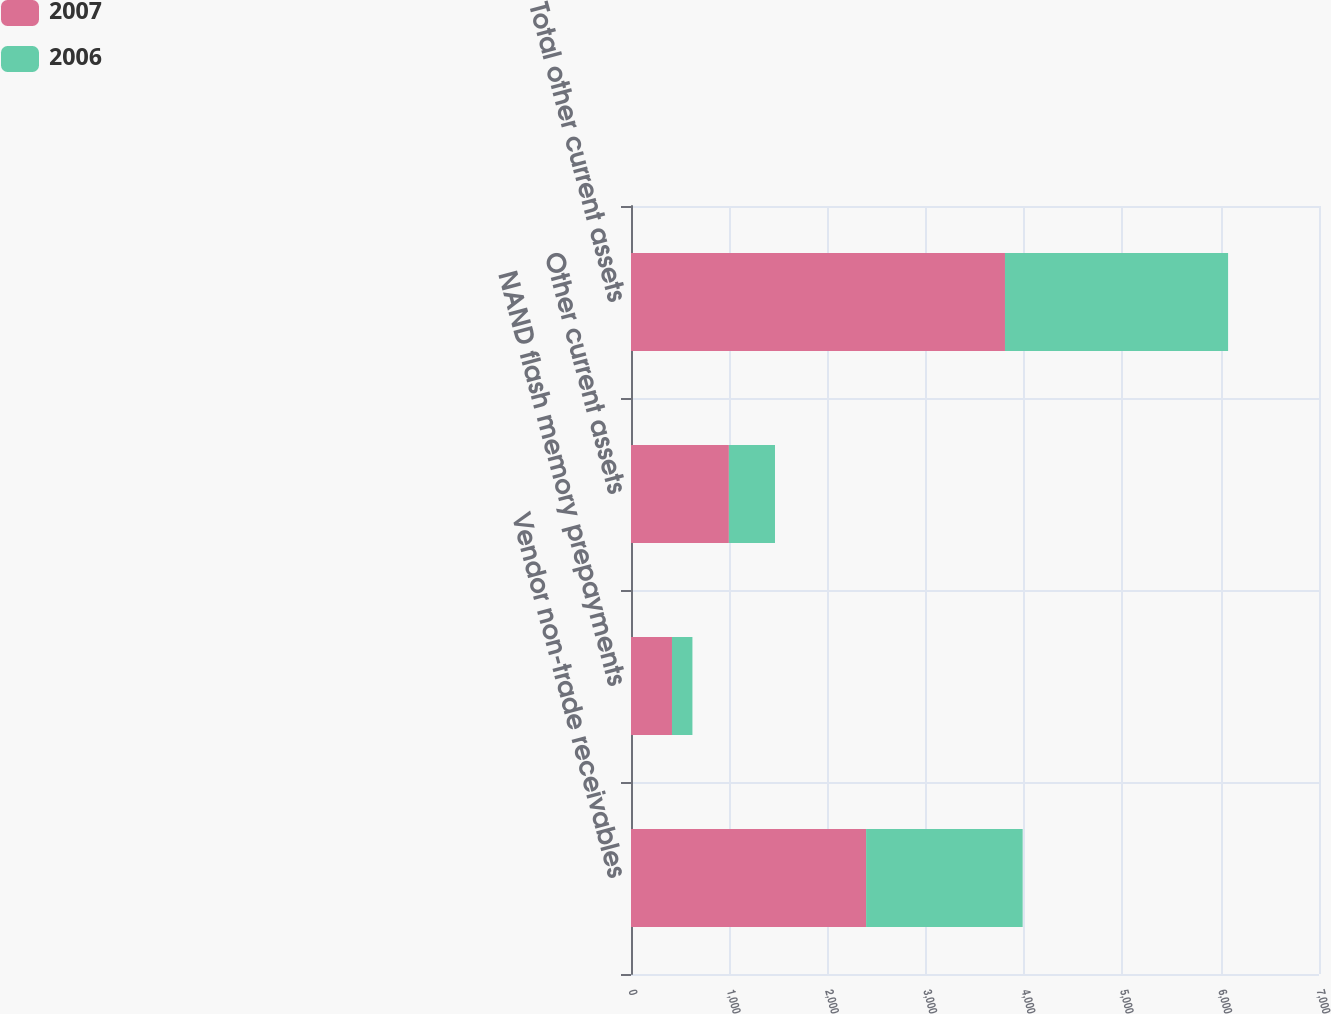Convert chart. <chart><loc_0><loc_0><loc_500><loc_500><stacked_bar_chart><ecel><fcel>Vendor non-trade receivables<fcel>NAND flash memory prepayments<fcel>Other current assets<fcel>Total other current assets<nl><fcel>2007<fcel>2392<fcel>417<fcel>996<fcel>3805<nl><fcel>2006<fcel>1593<fcel>208<fcel>469<fcel>2270<nl></chart> 